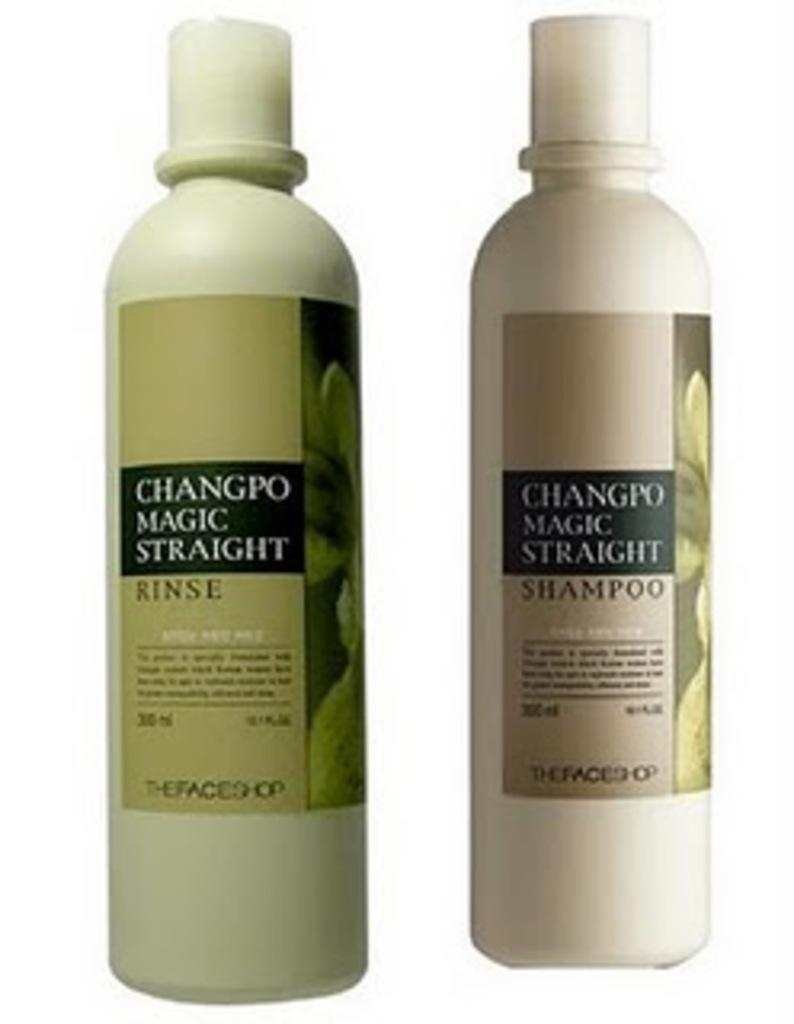<image>
Write a terse but informative summary of the picture. Two bottles of shampoo and conditioner called Changpo Magic Straight. 